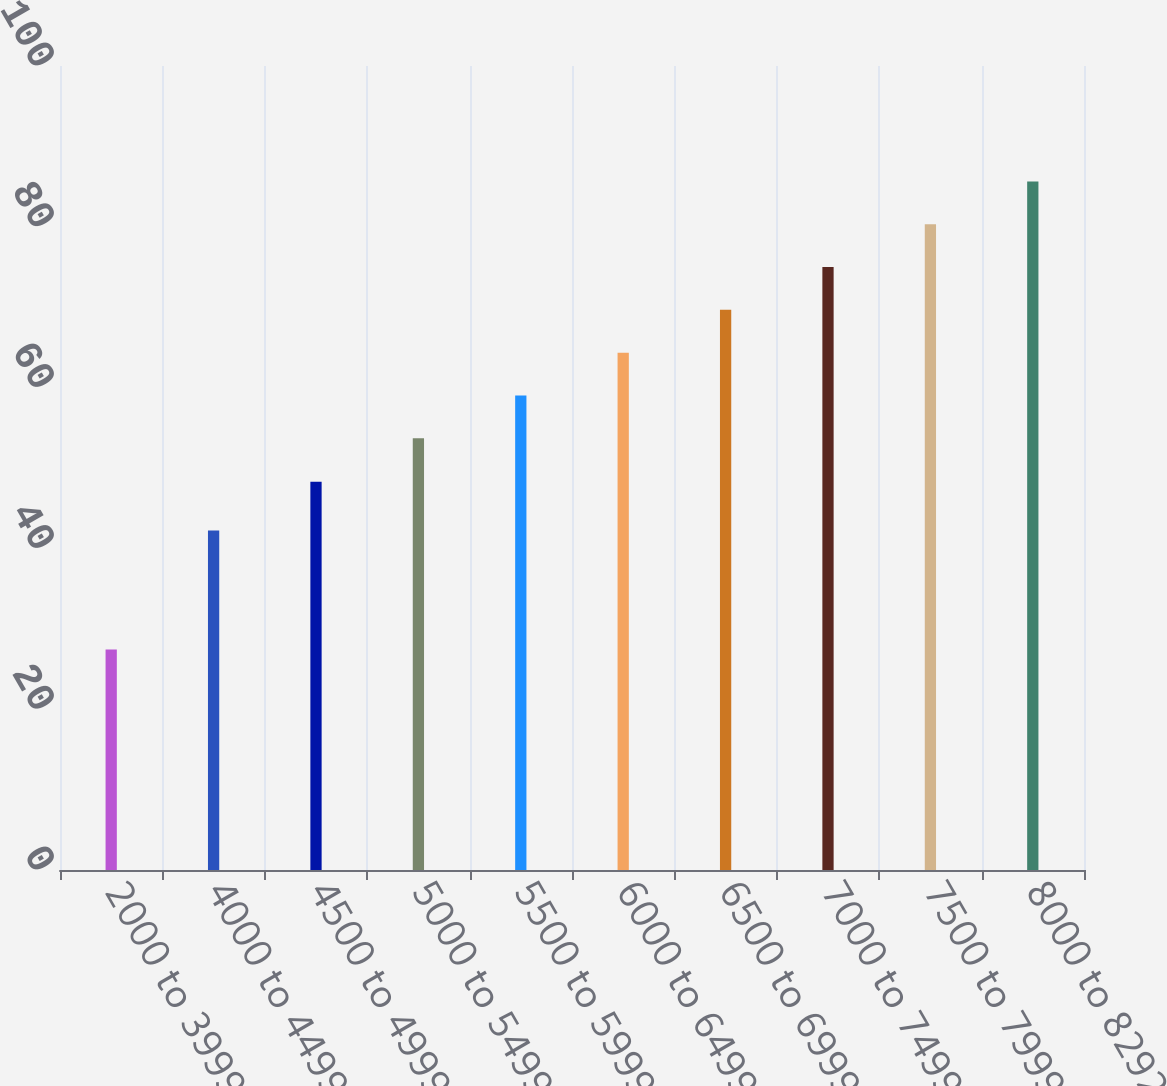Convert chart. <chart><loc_0><loc_0><loc_500><loc_500><bar_chart><fcel>2000 to 3999<fcel>4000 to 4499<fcel>4500 to 4999<fcel>5000 to 5499<fcel>5500 to 5999<fcel>6000 to 6499<fcel>6500 to 6999<fcel>7000 to 7499<fcel>7500 to 7999<fcel>8000 to 8292<nl><fcel>27.44<fcel>42.23<fcel>48.3<fcel>53.71<fcel>59.03<fcel>64.35<fcel>69.67<fcel>74.99<fcel>80.31<fcel>85.63<nl></chart> 